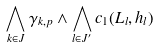<formula> <loc_0><loc_0><loc_500><loc_500>\bigwedge _ { k \in J } \gamma _ { k , p } \wedge \bigwedge _ { l \in J ^ { \prime } } c _ { 1 } ( L _ { l } , h _ { l } )</formula> 